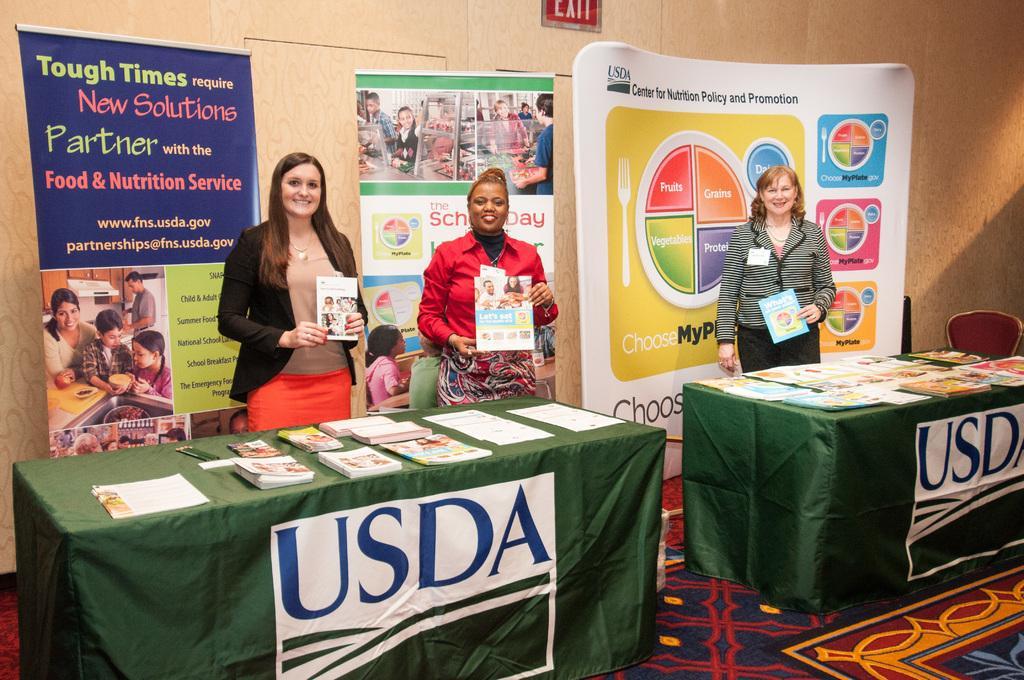Describe this image in one or two sentences. In this picture we can see three woman standing holding books in their hands and smiling and in front of them on table we have books, mobile, papers and in background we can see banners, wall, chair. 